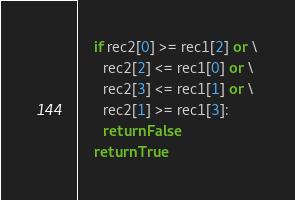Convert code to text. <code><loc_0><loc_0><loc_500><loc_500><_Python_>    if rec2[0] >= rec1[2] or \
      rec2[2] <= rec1[0] or \
      rec2[3] <= rec1[1] or \
      rec2[1] >= rec1[3]:
      return False
    return True
</code> 